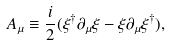<formula> <loc_0><loc_0><loc_500><loc_500>A _ { \mu } \equiv \frac { i } { 2 } ( \xi ^ { \dagger } \partial _ { \mu } \xi - \xi \partial _ { \mu } \xi ^ { \dagger } ) ,</formula> 